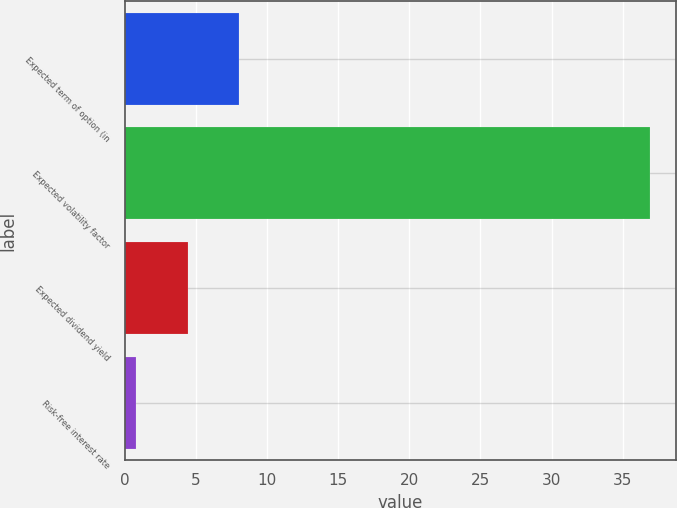<chart> <loc_0><loc_0><loc_500><loc_500><bar_chart><fcel>Expected term of option (in<fcel>Expected volatility factor<fcel>Expected dividend yield<fcel>Risk-free interest rate<nl><fcel>8.04<fcel>36.93<fcel>4.43<fcel>0.82<nl></chart> 